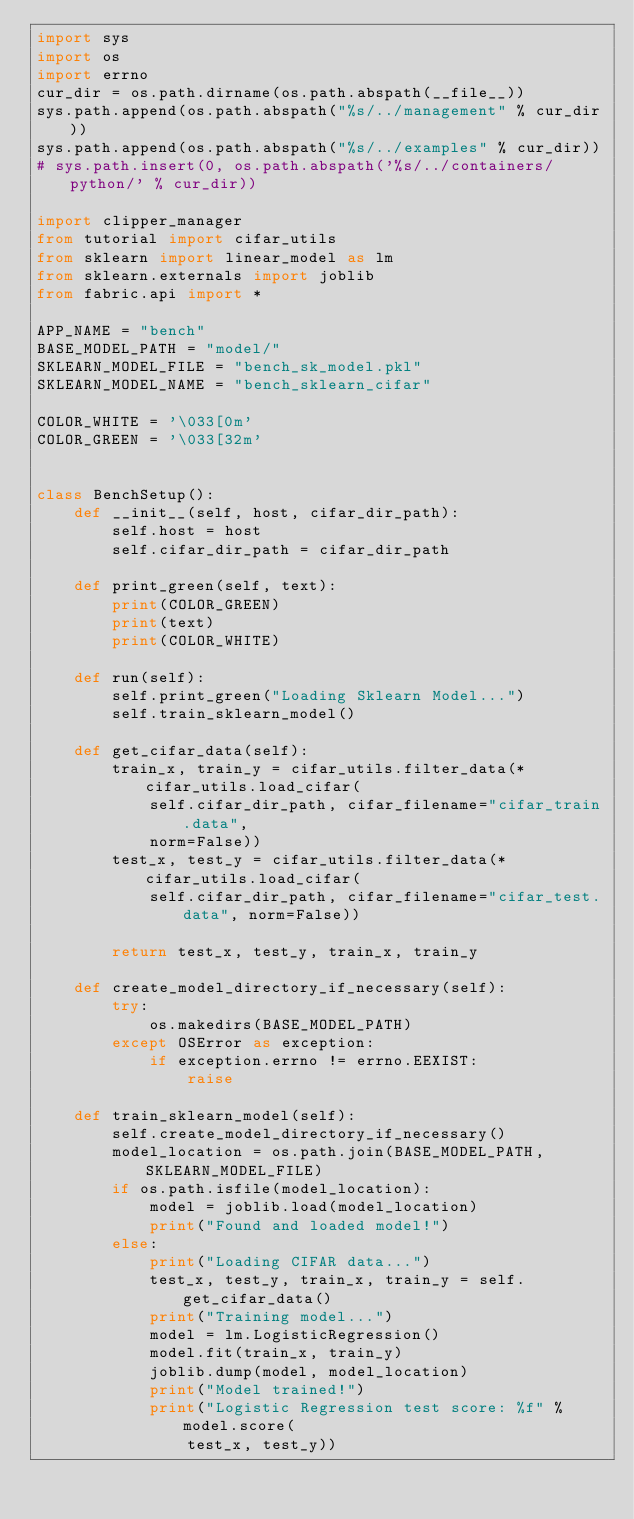Convert code to text. <code><loc_0><loc_0><loc_500><loc_500><_Python_>import sys
import os
import errno
cur_dir = os.path.dirname(os.path.abspath(__file__))
sys.path.append(os.path.abspath("%s/../management" % cur_dir))
sys.path.append(os.path.abspath("%s/../examples" % cur_dir))
# sys.path.insert(0, os.path.abspath('%s/../containers/python/' % cur_dir))

import clipper_manager
from tutorial import cifar_utils
from sklearn import linear_model as lm
from sklearn.externals import joblib
from fabric.api import *

APP_NAME = "bench"
BASE_MODEL_PATH = "model/"
SKLEARN_MODEL_FILE = "bench_sk_model.pkl"
SKLEARN_MODEL_NAME = "bench_sklearn_cifar"

COLOR_WHITE = '\033[0m'
COLOR_GREEN = '\033[32m'


class BenchSetup():
    def __init__(self, host, cifar_dir_path):
        self.host = host
        self.cifar_dir_path = cifar_dir_path

    def print_green(self, text):
        print(COLOR_GREEN)
        print(text)
        print(COLOR_WHITE)

    def run(self):
        self.print_green("Loading Sklearn Model...")
        self.train_sklearn_model()

    def get_cifar_data(self):
        train_x, train_y = cifar_utils.filter_data(*cifar_utils.load_cifar(
            self.cifar_dir_path, cifar_filename="cifar_train.data",
            norm=False))
        test_x, test_y = cifar_utils.filter_data(*cifar_utils.load_cifar(
            self.cifar_dir_path, cifar_filename="cifar_test.data", norm=False))

        return test_x, test_y, train_x, train_y

    def create_model_directory_if_necessary(self):
        try:
            os.makedirs(BASE_MODEL_PATH)
        except OSError as exception:
            if exception.errno != errno.EEXIST:
                raise

    def train_sklearn_model(self):
        self.create_model_directory_if_necessary()
        model_location = os.path.join(BASE_MODEL_PATH, SKLEARN_MODEL_FILE)
        if os.path.isfile(model_location):
            model = joblib.load(model_location)
            print("Found and loaded model!")
        else:
            print("Loading CIFAR data...")
            test_x, test_y, train_x, train_y = self.get_cifar_data()
            print("Training model...")
            model = lm.LogisticRegression()
            model.fit(train_x, train_y)
            joblib.dump(model, model_location)
            print("Model trained!")
            print("Logistic Regression test score: %f" % model.score(
                test_x, test_y))

</code> 